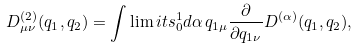<formula> <loc_0><loc_0><loc_500><loc_500>D ^ { ( 2 ) } _ { \mu \nu } ( q _ { 1 } , q _ { 2 } ) = \int \lim i t s _ { 0 } ^ { 1 } d \alpha \, q _ { 1 \mu } \frac { \partial } { \partial q _ { 1 \nu } } D ^ { ( \alpha ) } ( q _ { 1 } , q _ { 2 } ) ,</formula> 